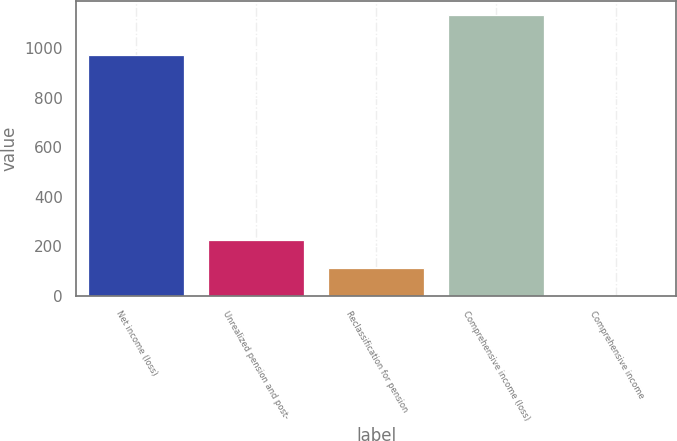<chart> <loc_0><loc_0><loc_500><loc_500><bar_chart><fcel>Net income (loss)<fcel>Unrealized pension and post-<fcel>Reclassification for pension<fcel>Comprehensive income (loss)<fcel>Comprehensive income<nl><fcel>972.3<fcel>227.64<fcel>114.17<fcel>1134.7<fcel>0.7<nl></chart> 